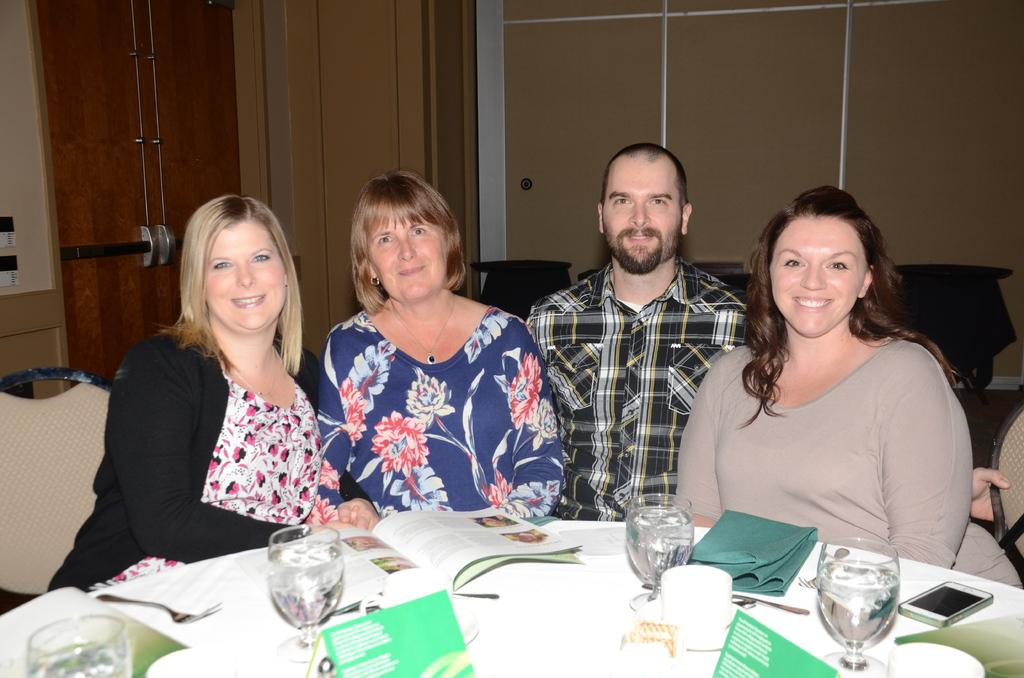How many people are in the image? There are four persons in the image. What are the four persons doing in the image? The four persons are sitting on chairs. What is present on the table in the image? There is a cloth, a book, a card, a glass, a cup, a mobile, and a fork on the table. Which person's leg is resting on the side of the table in the image? There is no indication in the image that any person's leg is resting on the side of the table. How many knees are visible in the image? There is no specific mention of knees in the image, as the focus is on the people sitting on chairs and the items on the table. 